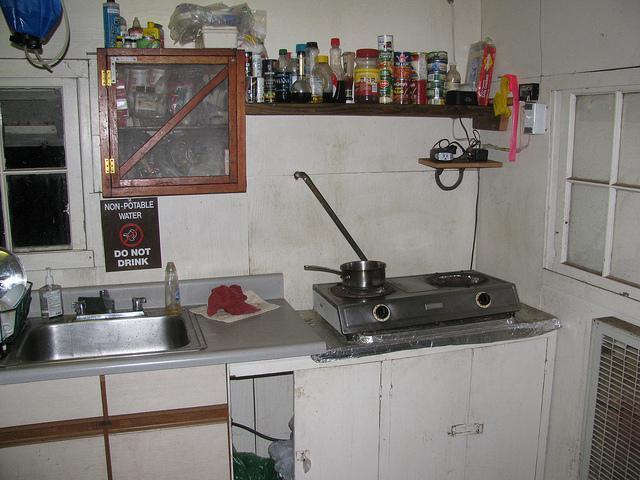How many burners?
Give a very brief answer. 2. How many burners are on the stove?
Give a very brief answer. 2. 